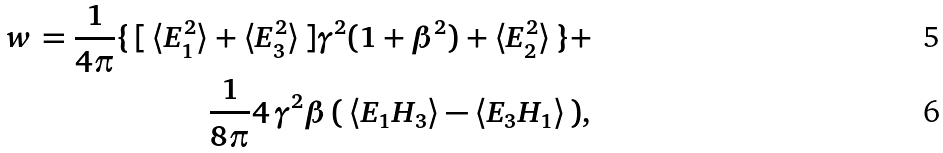Convert formula to latex. <formula><loc_0><loc_0><loc_500><loc_500>w = \frac { 1 } { 4 \pi } \{ \, [ \, \langle E _ { 1 } ^ { 2 } \rangle + \langle E _ { 3 } ^ { 2 } \rangle \, ] \gamma ^ { 2 } ( 1 + \beta ^ { 2 } ) + \langle E _ { 2 } ^ { 2 } \rangle \, \} + \\ \frac { 1 } { 8 \pi } 4 \, \gamma ^ { 2 } \beta \, ( \, \langle E _ { 1 } H _ { 3 } \rangle - \langle E _ { 3 } H _ { 1 } \rangle \, ) ,</formula> 